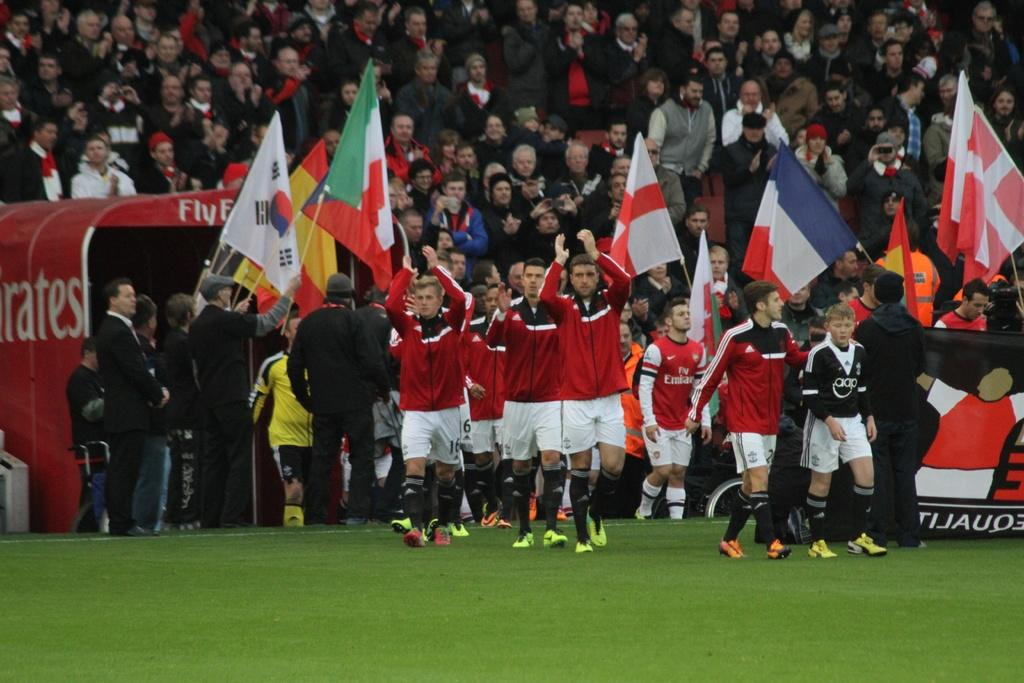Where was the image taken? The image was taken in a playground. What are the people in the image doing? There are persons walking and standing in the image. Can you describe the actions of the standing persons? Some of the standing persons are holding flags. What can be seen in the background of the image? There are many people standing in the background of the image. What type of pail can be seen being used by the children in the image? There is no pail visible in the image; it is set in a playground, but no specific playground equipment is mentioned. 